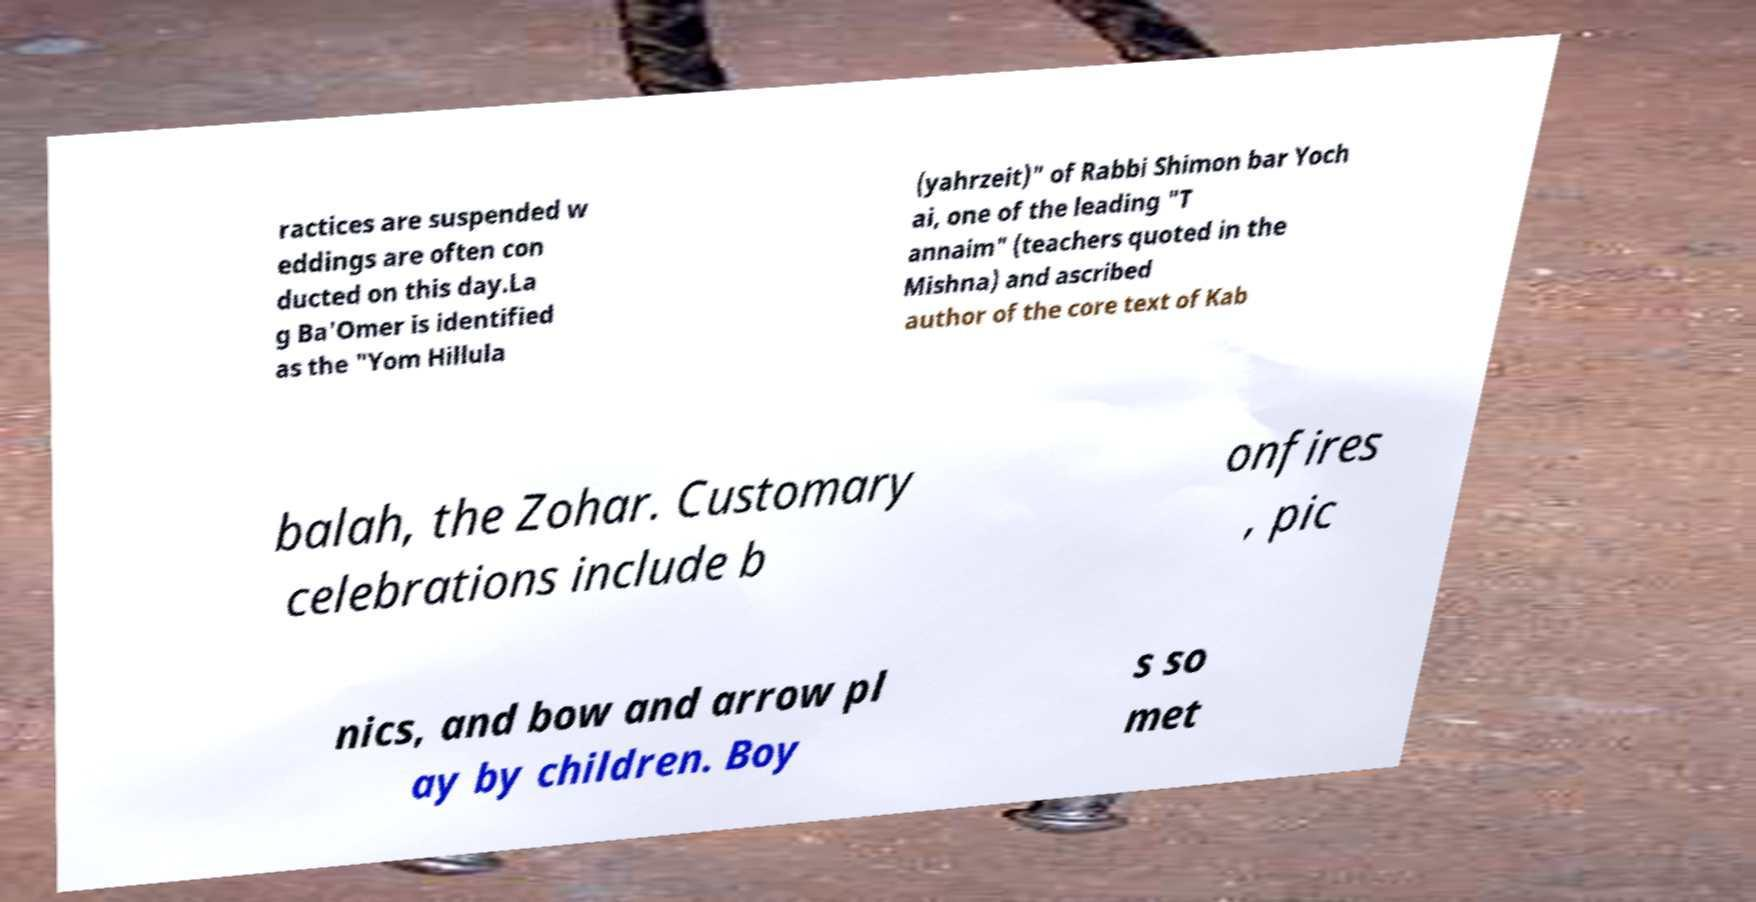I need the written content from this picture converted into text. Can you do that? ractices are suspended w eddings are often con ducted on this day.La g Ba'Omer is identified as the "Yom Hillula (yahrzeit)" of Rabbi Shimon bar Yoch ai, one of the leading "T annaim" (teachers quoted in the Mishna) and ascribed author of the core text of Kab balah, the Zohar. Customary celebrations include b onfires , pic nics, and bow and arrow pl ay by children. Boy s so met 